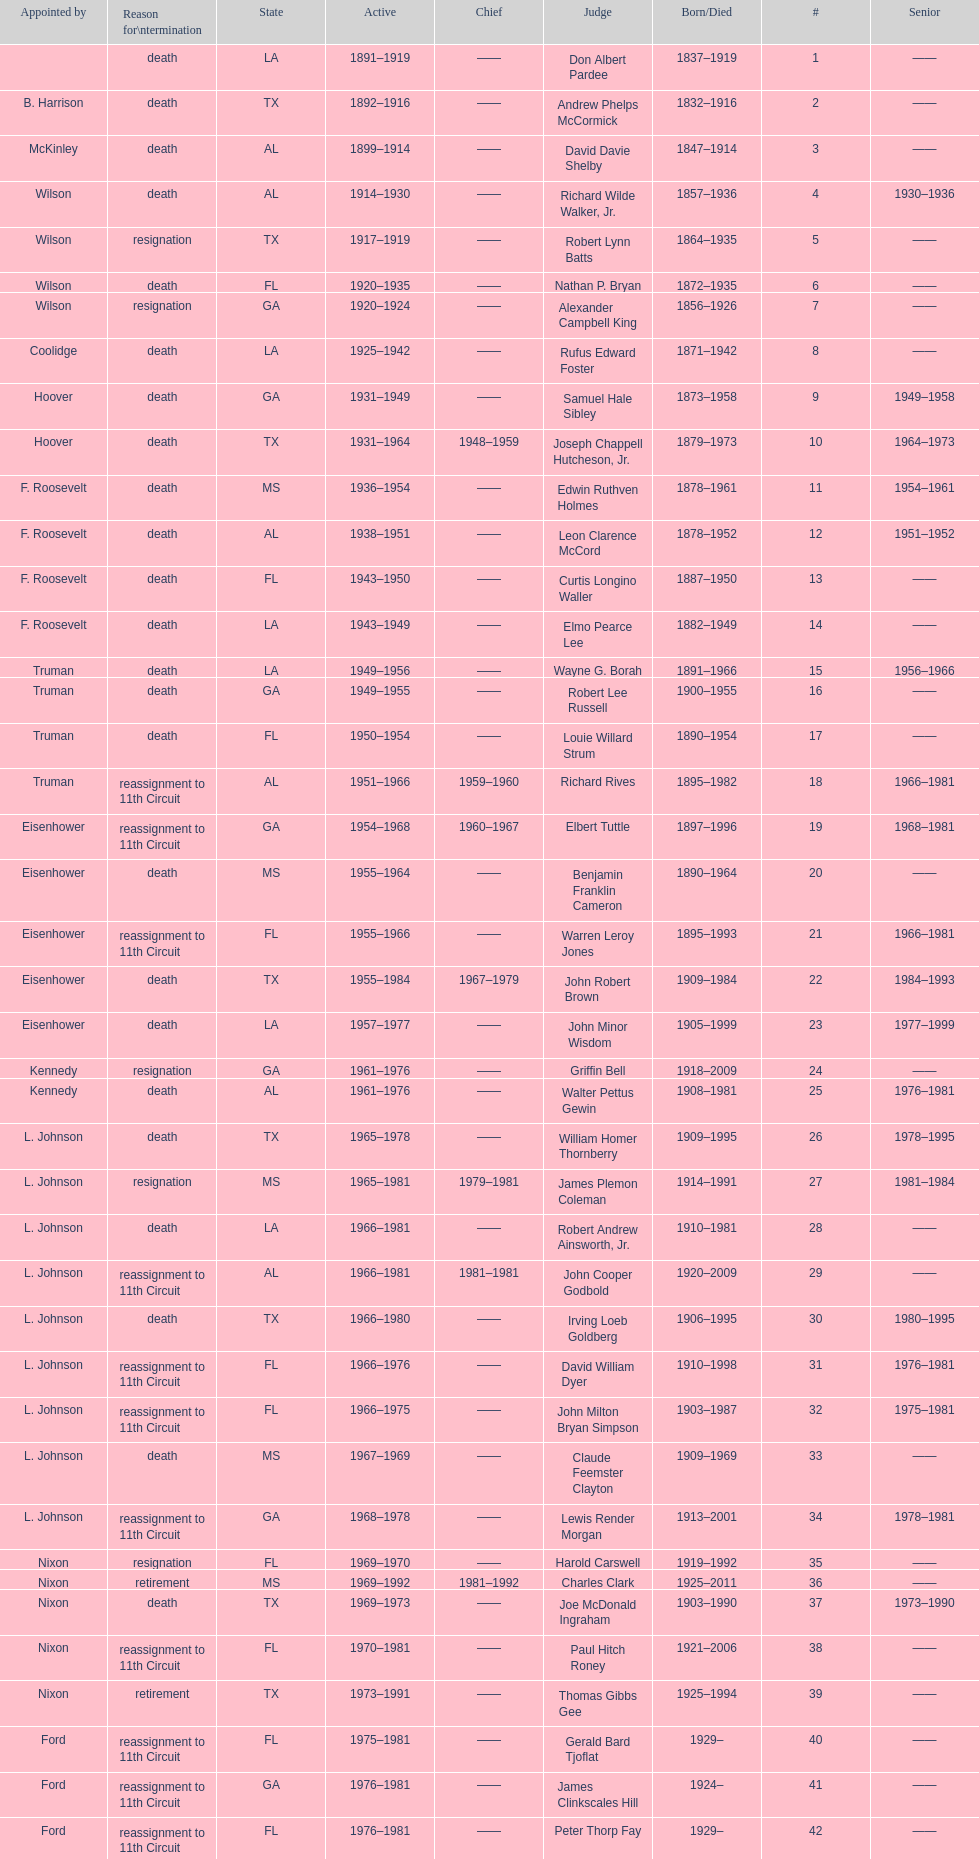Which judge was last appointed by president truman? Richard Rives. 